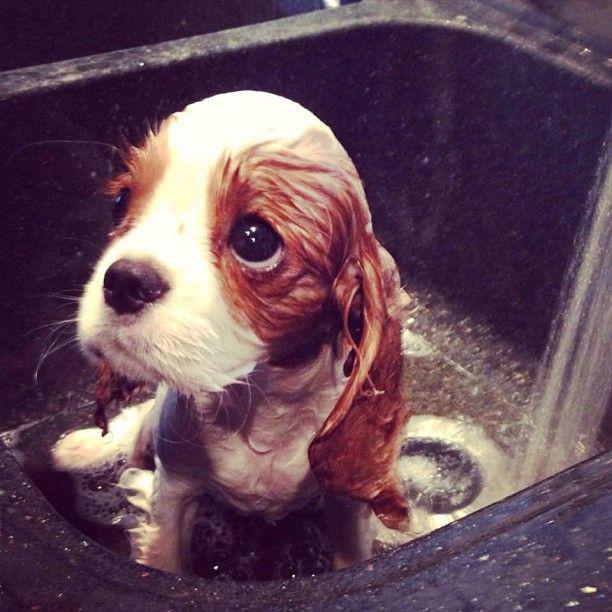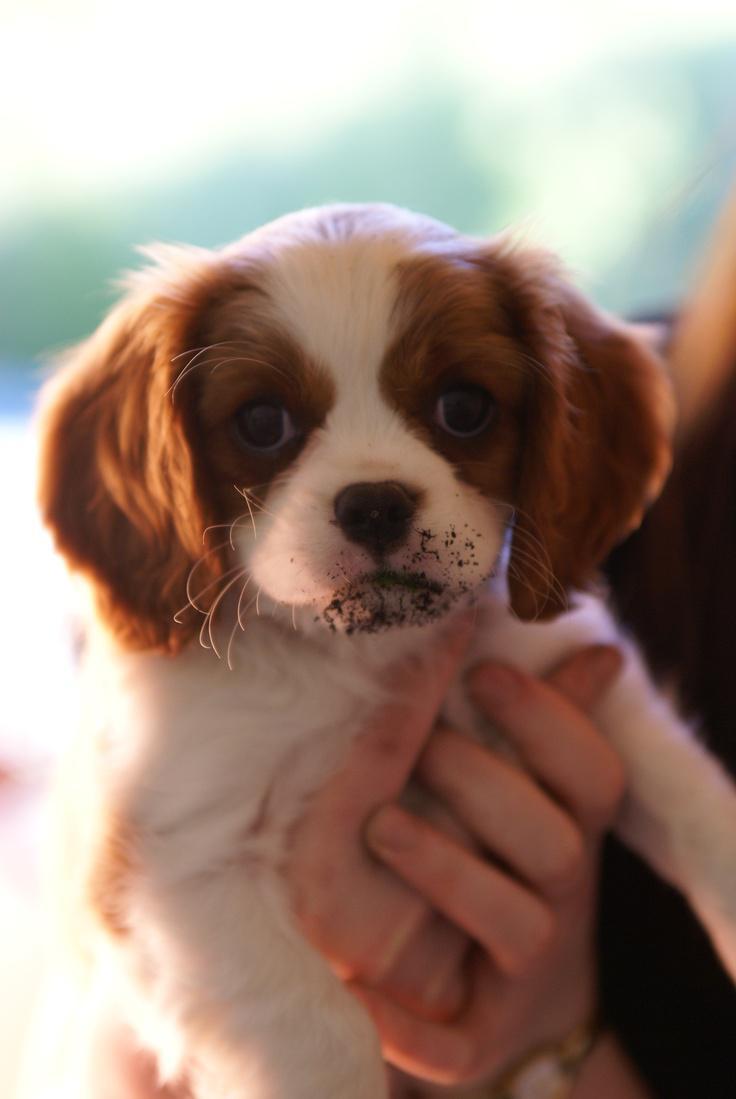The first image is the image on the left, the second image is the image on the right. Assess this claim about the two images: "Each image contains one 'real' live spaniel with dry orange-and-white fur, and one dog is posed on folds of pale fabric.". Correct or not? Answer yes or no. No. The first image is the image on the left, the second image is the image on the right. Examine the images to the left and right. Is the description "A person is holding the dog in the image on the right." accurate? Answer yes or no. Yes. 